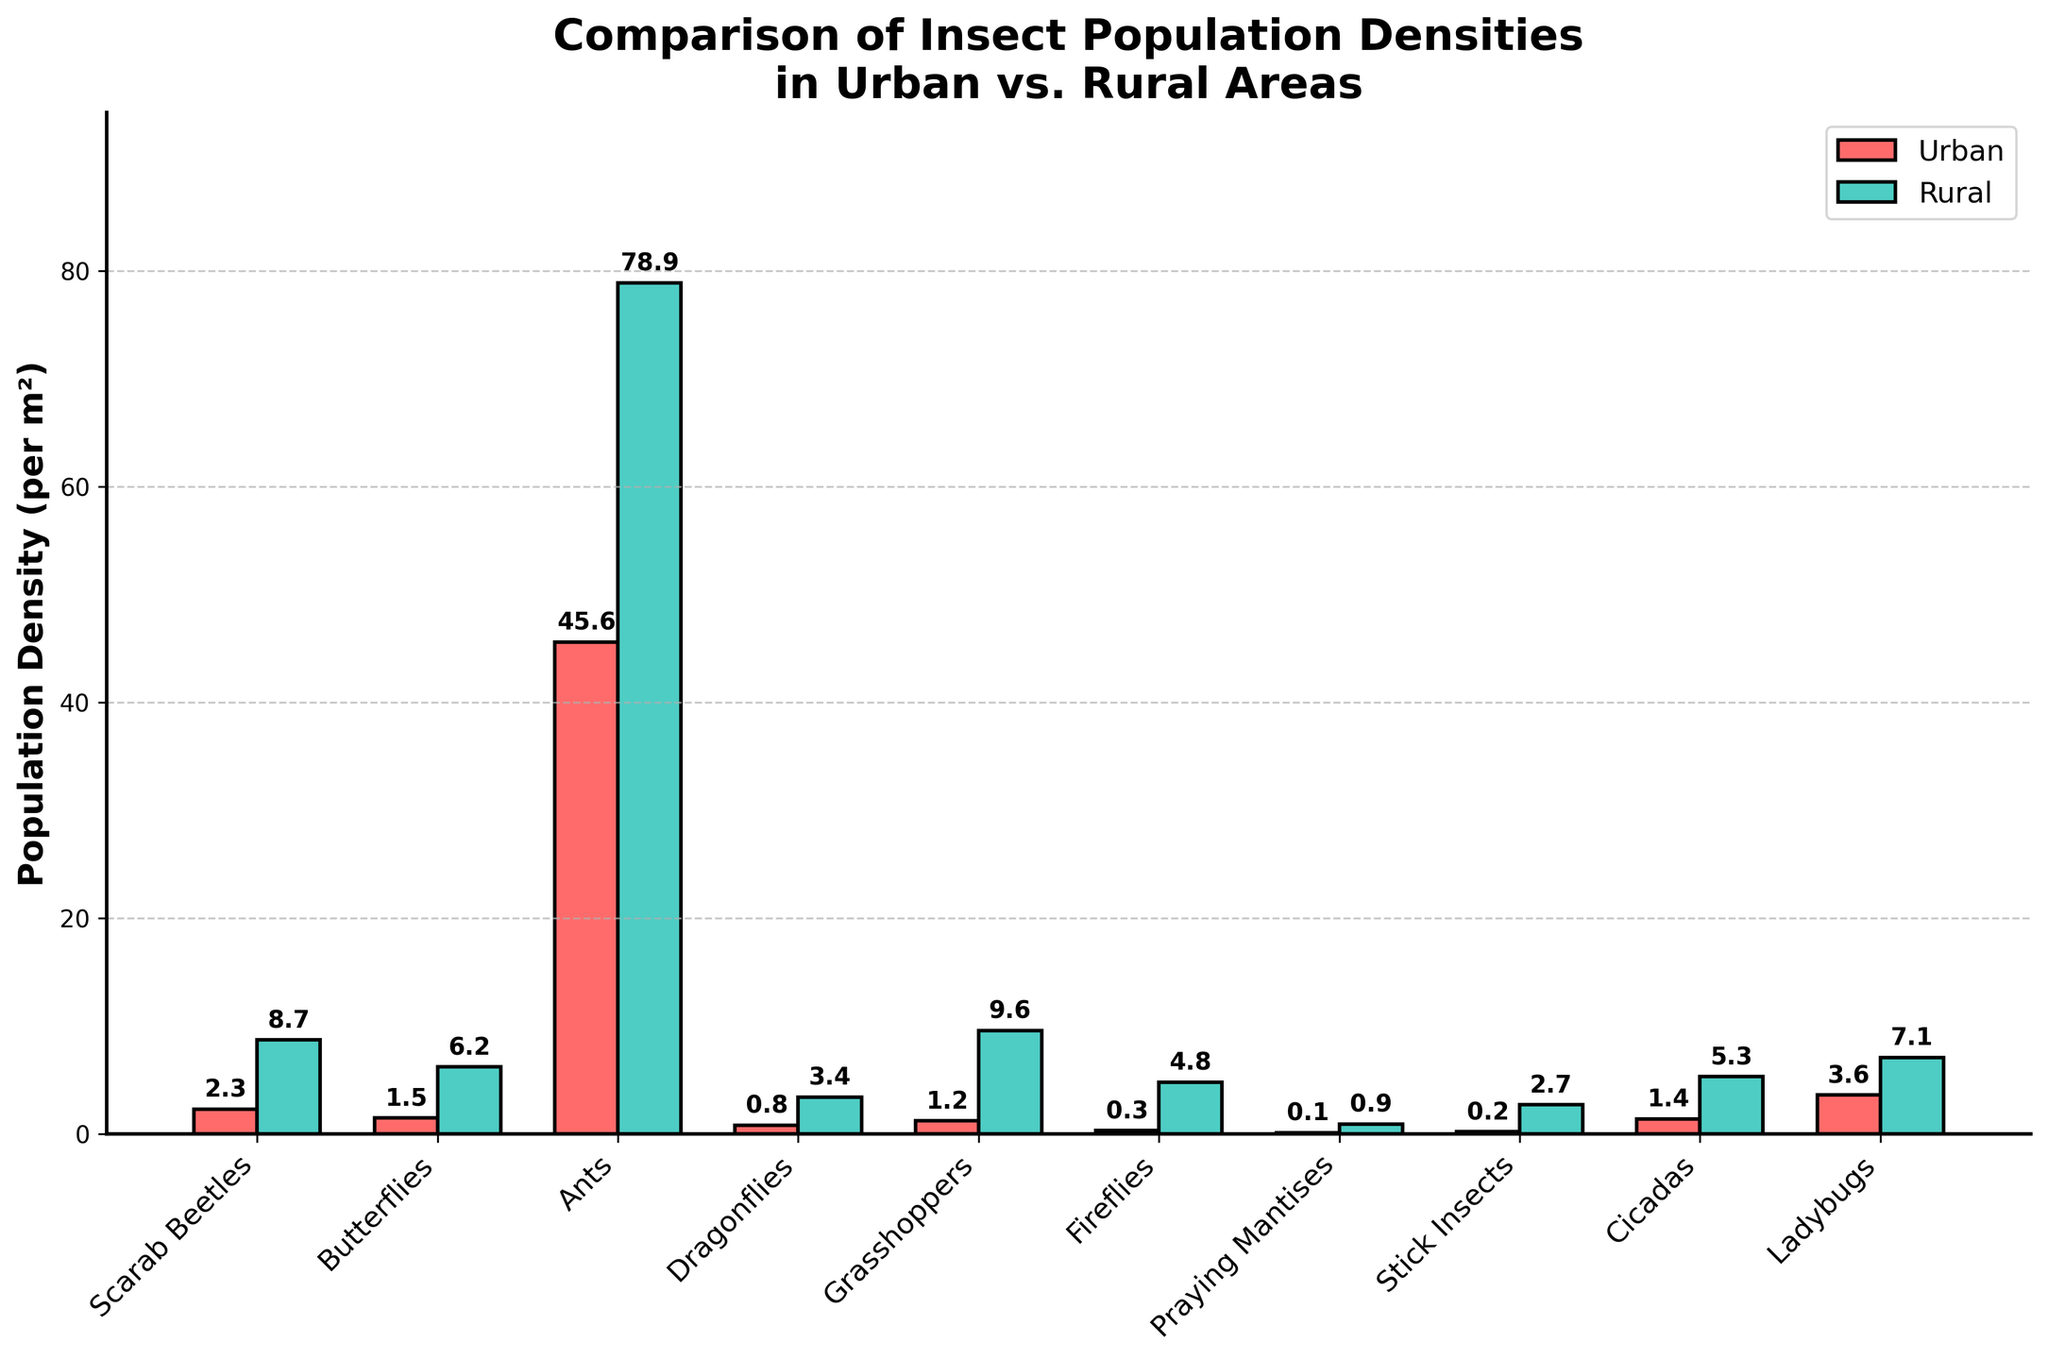Which insect type has the highest population density in rural areas? Look for the tallest bar in the rural category (green bars). The tallest bar corresponds to Ants.
Answer: Ants What is the difference in population density between Ants in urban and rural areas? Check the height of the bars for Ants in both urban and rural areas. Urban density for Ants is 45.6 per m², and rural density for Ants is 78.9 per m². The difference is 78.9 - 45.6.
Answer: 33.3 What is the combined population density of Grasshoppers and Fireflies in urban areas? Sum the heights of the bars for Grasshoppers and Fireflies in the urban category. Grasshoppers have a density of 1.2 per m² and Fireflies have a density of 0.3 per m². The total is 1.2 + 0.3.
Answer: 1.5 Which insect type shows the least difference in population density between urban and rural areas? Compare the differences between urban and rural densities for all insect types. Praying Mantises have the smallest difference (0.9 - 0.1).
Answer: Praying Mantises Are there any insect types where urban population density is higher than rural? If so, which ones? Compare each pair of bars for urban and rural categories. No urban bar is taller than its rural counterpart.
Answer: No What is the average population density of Cicadas in both urban and rural areas? Sum the urban and rural densities for Cicadas and then divide by 2. Urban density is 1.4 per m², and rural density is 5.3 per m². The average is (1.4 + 5.3) / 2.
Answer: 3.35 Which insect has a higher urban population density: Butterflies or Ladybugs? Compare the height of the urban bars for Butterflies and Ladybugs. Urban density of Butterflies is 1.5 per m², while Ladybugs have a density of 3.6 per m².
Answer: Ladybugs For which insect type is the population density difference the greatest between urban and rural areas? Calculate the differences for each insect type and identify the largest. Grasshoppers have the largest difference (9.6 - 1.2 = 8.4).
Answer: Grasshoppers What is the population density of Stick Insects in urban areas? Look at the height of the urban bar for Stick Insects. The urban density is 0.2 per m².
Answer: 0.2 